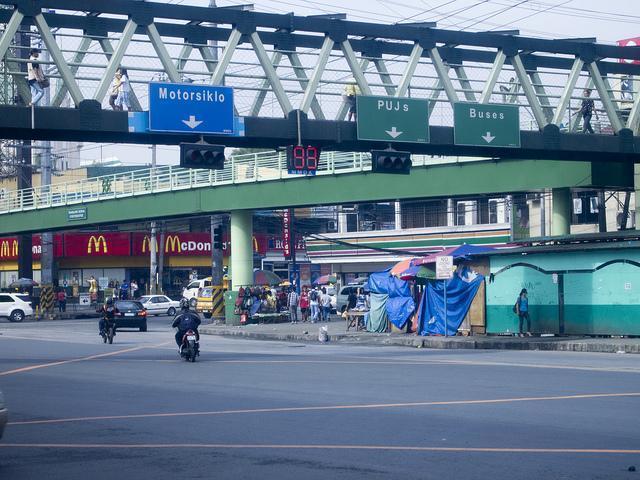What is the meaning of the arrows on the sign?
Select the accurate answer and provide justification: `Answer: choice
Rationale: srationale.`
Options: Merge left, one way, turn right, go straight. Answer: go straight.
Rationale: The arrows are pointing straight ahead on the road and they mean to continue forward to reach those destinations. 